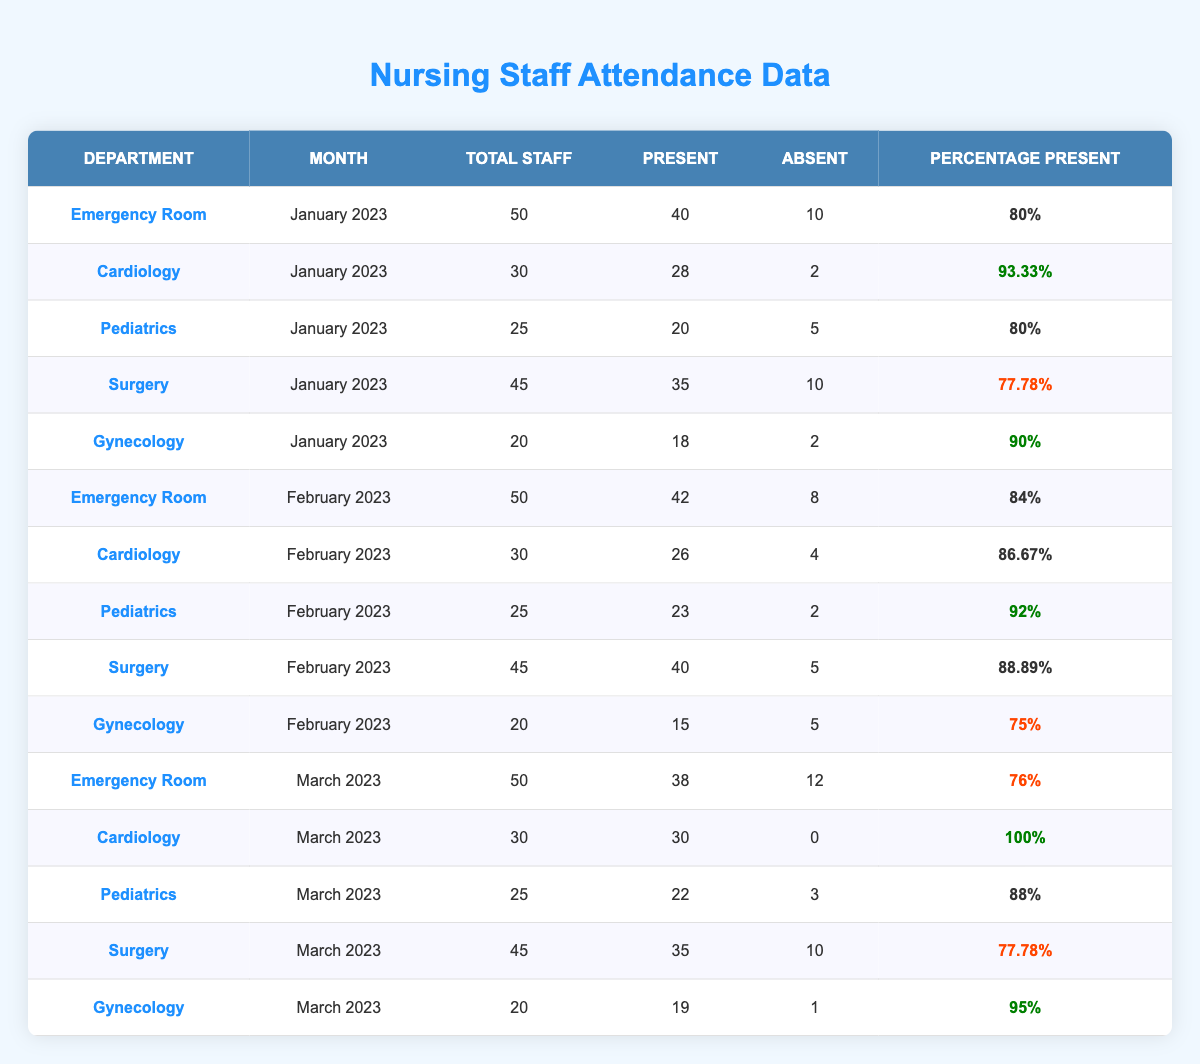What department had the highest attendance percentage in January 2023? In January 2023, the data shows that Cardiology had a percentage present of 93.33%, which is the highest compared to other departments in that month.
Answer: Cardiology How many staff were absent in the Surgery department in February 2023? The table shows that in February 2023, Surgery had 5 staff members absent, which can be found directly in the attendance data for that month.
Answer: 5 What is the total number of present staff across all departments in March 2023? The present staff in March 2023 are: Emergency Room (38) + Cardiology (30) + Pediatrics (22) + Surgery (35) + Gynecology (19) = 144. Therefore, the total number of present staff is 144.
Answer: 144 Did the Pediatrics department have higher attendance in February 2023 than in March 2023? In February 2023, Pediatrics had 23 staff present (92%), and in March 2023, they had 22 staff present (88%). Since 23 is greater than 22, Pediatrics had higher attendance in February.
Answer: Yes Which month had the lowest attendance percentage in the Gynecology department? The attendance percentages for Gynecology are: January 2023 (90%), February 2023 (75%), and March 2023 (95%). The lowest percentage is 75% in February 2023.
Answer: February 2023 What is the average attendance percentage for the Emergency Room over the three months? The attendance percentages for the Emergency Room are: January (80%), February (84%), and March (76%). To find the average: (80 + 84 + 76) / 3 = 80%. Thus, the average is 80%.
Answer: 80% How many total staff were present in the Cardiology department across all months? The present staff for Cardiology are: 28 in January, 26 in February, and 30 in March, which totals: 28 + 26 + 30 = 84. So, the total present staff is 84.
Answer: 84 Which department had the lowest attendance percentage overall? The overall percentages were: Emergency Room (76%, 80%, 84%), Cardiology (100%, 86.67%, 93.33%), Pediatrics (88%, 92%, 80%), Surgery (77.78%, 88.89%, 77.78%), and Gynecology (90%, 75%, 95%). The lowest attendance percentage belongs to Surgery with 77.78% in both January and March. Therefore, the department with the lowest attendance percentage is Surgery.
Answer: Surgery Was there any month where the total staff present in the Surgery department was above 40? In the months of January (35 present) and March (35 present), the present staff in Surgery was not above 40, while in February, they had 40 present. Thus, February is the only month where the attendance was above 40.
Answer: Yes How many total staff were involved in the attendance reporting for the Pediatrics department? The total staff for Pediatrics across the three months were: 25 in January, 25 in February, and 25 in March. The total equals: 25 + 25 + 25 = 75.
Answer: 75 In which month did the Gynecology department have its highest attendance percentage? The Gynecology percentages are: January (90%), February (75%), and March (95%). The highest attendance percentage is 95% in March 2023.
Answer: March 2023 